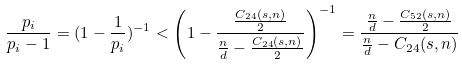Convert formula to latex. <formula><loc_0><loc_0><loc_500><loc_500>\frac { p _ { i } } { p _ { i } - 1 } = ( 1 - \frac { 1 } { p _ { i } } ) ^ { - 1 } < \left ( 1 - \frac { \frac { C _ { 2 4 } ( s , n ) } { 2 } } { \frac { n } { d } - \frac { C _ { 2 4 } ( s , n ) } { 2 } } \right ) ^ { - 1 } = \frac { \frac { n } { d } - \frac { C _ { 5 2 } ( s , n ) } { 2 } } { \frac { n } { d } - C _ { 2 4 } ( s , n ) }</formula> 